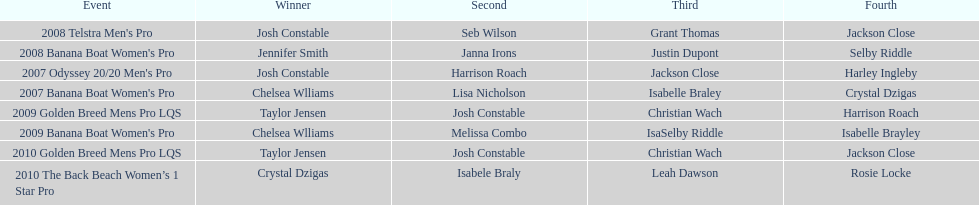Name each of the years that taylor jensen was winner. 2009, 2010. 